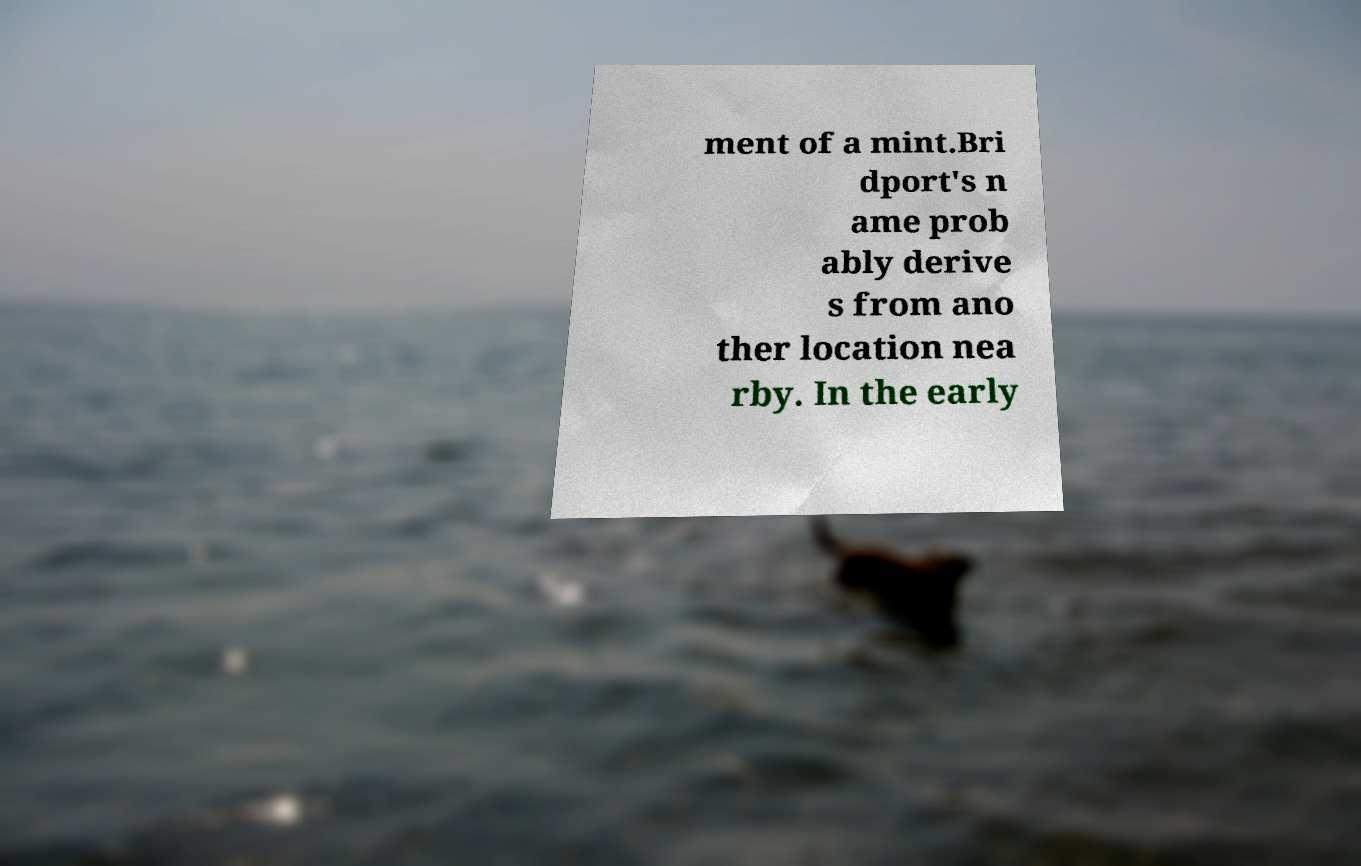Please read and relay the text visible in this image. What does it say? ment of a mint.Bri dport's n ame prob ably derive s from ano ther location nea rby. In the early 